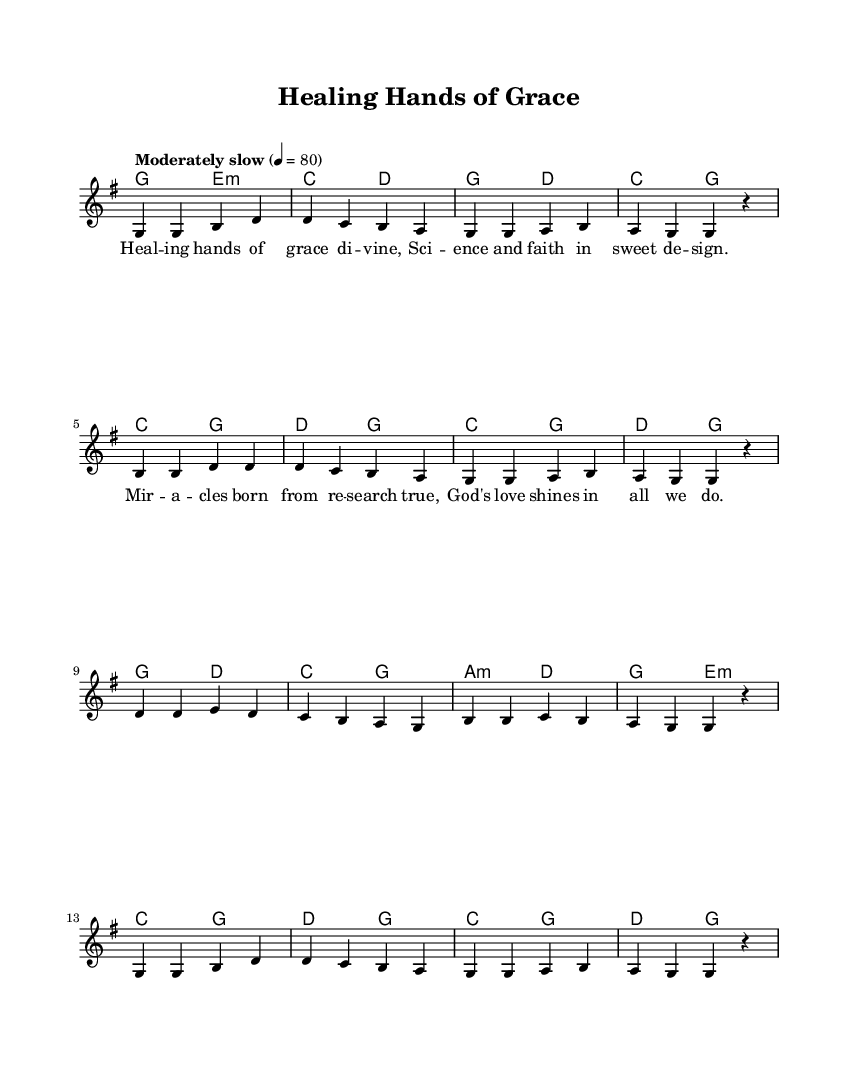What is the key signature of this music? The key signature is G major, which has one sharp (F#) indicated at the beginning of the staff.
Answer: G major What is the time signature of this music? The time signature is found at the beginning of the piece, specifically indicated by the "4/4" symbol, which means there are four beats per measure.
Answer: 4/4 What is the tempo marking of this music? The tempo marking is "Moderately slow" with a tempo of quarter note equal to 80, indicating a moderate speed for the piece.
Answer: Moderately slow How many measures are in the melody section? By counting the measures in the melody given, there are a total of 12 measures present in this piece.
Answer: 12 What is the primary theme of the lyrics? The lyrics focus on themes of healing and the collaboration of science and faith, emphasizing divine grace and research's role in miracles.
Answer: Healing and science What is the last note of the piece? The last note of the melody in the score is a rest, specifically notated with an "r," signifying silence at the end of the musical phrase.
Answer: Rest 